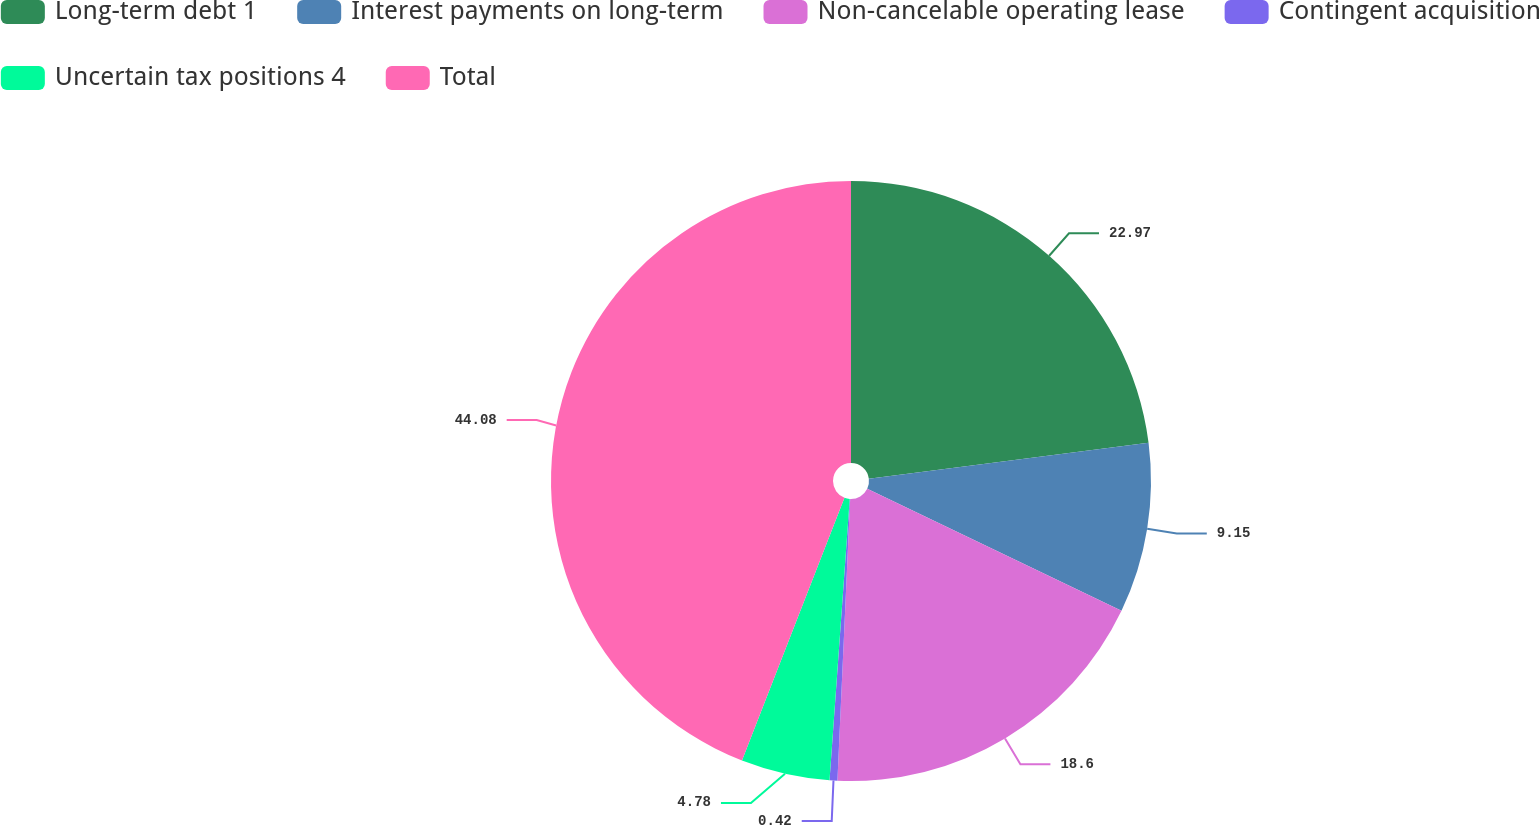Convert chart. <chart><loc_0><loc_0><loc_500><loc_500><pie_chart><fcel>Long-term debt 1<fcel>Interest payments on long-term<fcel>Non-cancelable operating lease<fcel>Contingent acquisition<fcel>Uncertain tax positions 4<fcel>Total<nl><fcel>22.97%<fcel>9.15%<fcel>18.6%<fcel>0.42%<fcel>4.78%<fcel>44.08%<nl></chart> 